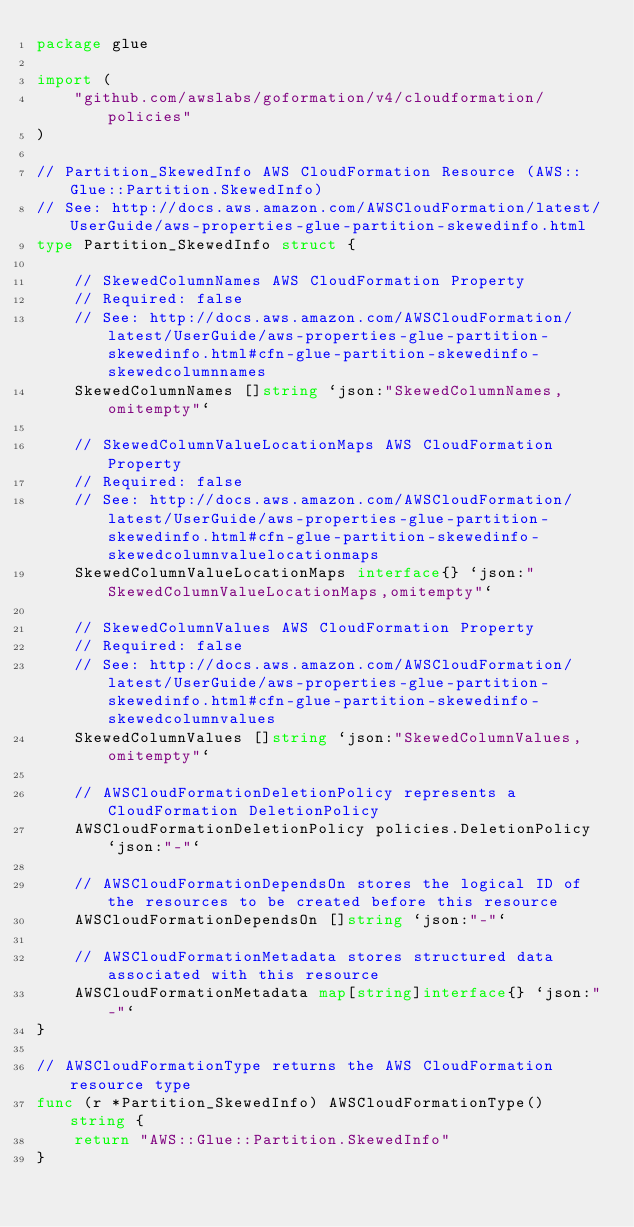<code> <loc_0><loc_0><loc_500><loc_500><_Go_>package glue

import (
	"github.com/awslabs/goformation/v4/cloudformation/policies"
)

// Partition_SkewedInfo AWS CloudFormation Resource (AWS::Glue::Partition.SkewedInfo)
// See: http://docs.aws.amazon.com/AWSCloudFormation/latest/UserGuide/aws-properties-glue-partition-skewedinfo.html
type Partition_SkewedInfo struct {

	// SkewedColumnNames AWS CloudFormation Property
	// Required: false
	// See: http://docs.aws.amazon.com/AWSCloudFormation/latest/UserGuide/aws-properties-glue-partition-skewedinfo.html#cfn-glue-partition-skewedinfo-skewedcolumnnames
	SkewedColumnNames []string `json:"SkewedColumnNames,omitempty"`

	// SkewedColumnValueLocationMaps AWS CloudFormation Property
	// Required: false
	// See: http://docs.aws.amazon.com/AWSCloudFormation/latest/UserGuide/aws-properties-glue-partition-skewedinfo.html#cfn-glue-partition-skewedinfo-skewedcolumnvaluelocationmaps
	SkewedColumnValueLocationMaps interface{} `json:"SkewedColumnValueLocationMaps,omitempty"`

	// SkewedColumnValues AWS CloudFormation Property
	// Required: false
	// See: http://docs.aws.amazon.com/AWSCloudFormation/latest/UserGuide/aws-properties-glue-partition-skewedinfo.html#cfn-glue-partition-skewedinfo-skewedcolumnvalues
	SkewedColumnValues []string `json:"SkewedColumnValues,omitempty"`

	// AWSCloudFormationDeletionPolicy represents a CloudFormation DeletionPolicy
	AWSCloudFormationDeletionPolicy policies.DeletionPolicy `json:"-"`

	// AWSCloudFormationDependsOn stores the logical ID of the resources to be created before this resource
	AWSCloudFormationDependsOn []string `json:"-"`

	// AWSCloudFormationMetadata stores structured data associated with this resource
	AWSCloudFormationMetadata map[string]interface{} `json:"-"`
}

// AWSCloudFormationType returns the AWS CloudFormation resource type
func (r *Partition_SkewedInfo) AWSCloudFormationType() string {
	return "AWS::Glue::Partition.SkewedInfo"
}
</code> 